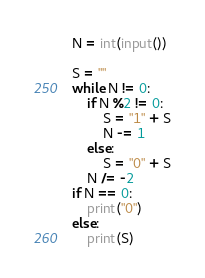Convert code to text. <code><loc_0><loc_0><loc_500><loc_500><_Python_>N = int(input())

S = ""
while N != 0:
    if N %2 != 0:
        S = "1" + S
        N -= 1
    else:
        S = "0" + S
    N /= -2
if N == 0:
    print("0")
else:
    print(S)</code> 